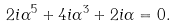<formula> <loc_0><loc_0><loc_500><loc_500>2 i \alpha ^ { 5 } + 4 i \alpha ^ { 3 } + 2 i \alpha = 0 .</formula> 